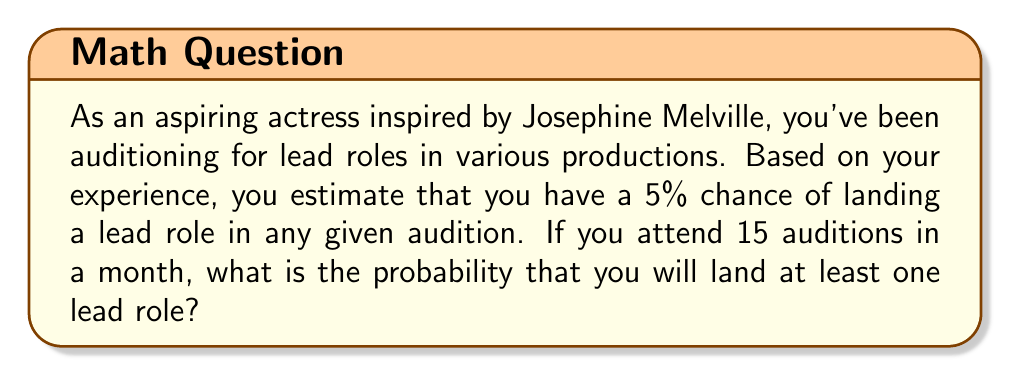Show me your answer to this math problem. To solve this problem, we'll use the binomial probability distribution and the complement rule.

1. Let's define our variables:
   $p$ = probability of success (landing a lead role) in a single audition = 0.05
   $n$ = number of auditions = 15
   $X$ = number of lead roles landed

2. We want to find $P(X \geq 1)$, the probability of landing at least one lead role.

3. It's easier to calculate the complement of this probability: the probability of not landing any lead roles, and then subtract it from 1.

4. The probability of not landing any lead roles is:
   $P(X = 0) = \binom{n}{0} p^0 (1-p)^n$

5. Simplifying:
   $P(X = 0) = (1-p)^n = (0.95)^{15}$

6. Now, we can calculate the probability of landing at least one lead role:
   $P(X \geq 1) = 1 - P(X = 0) = 1 - (0.95)^{15}$

7. Using a calculator or computer:
   $(0.95)^{15} \approx 0.4633$
   $1 - 0.4633 \approx 0.5367$

8. Converting to a percentage:
   $0.5367 \times 100\% \approx 53.67\%$

Therefore, the probability of landing at least one lead role in 15 auditions is approximately 53.67%.
Answer: The probability of landing at least one lead role in 15 auditions is approximately 53.67%. 